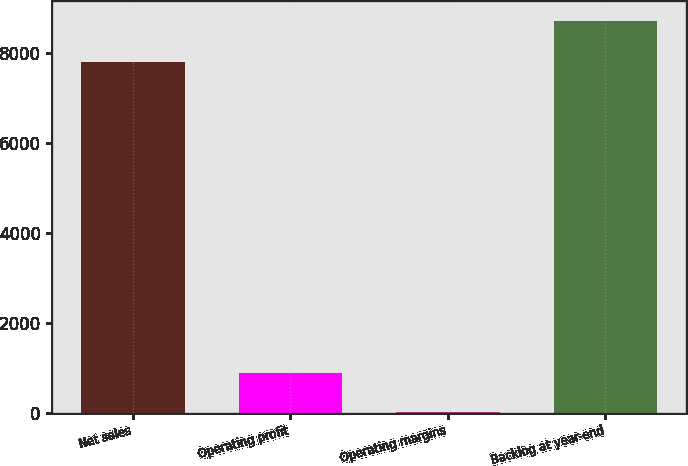Convert chart. <chart><loc_0><loc_0><loc_500><loc_500><bar_chart><fcel>Net sales<fcel>Operating profit<fcel>Operating margins<fcel>Backlog at year-end<nl><fcel>7788<fcel>878.1<fcel>9<fcel>8700<nl></chart> 